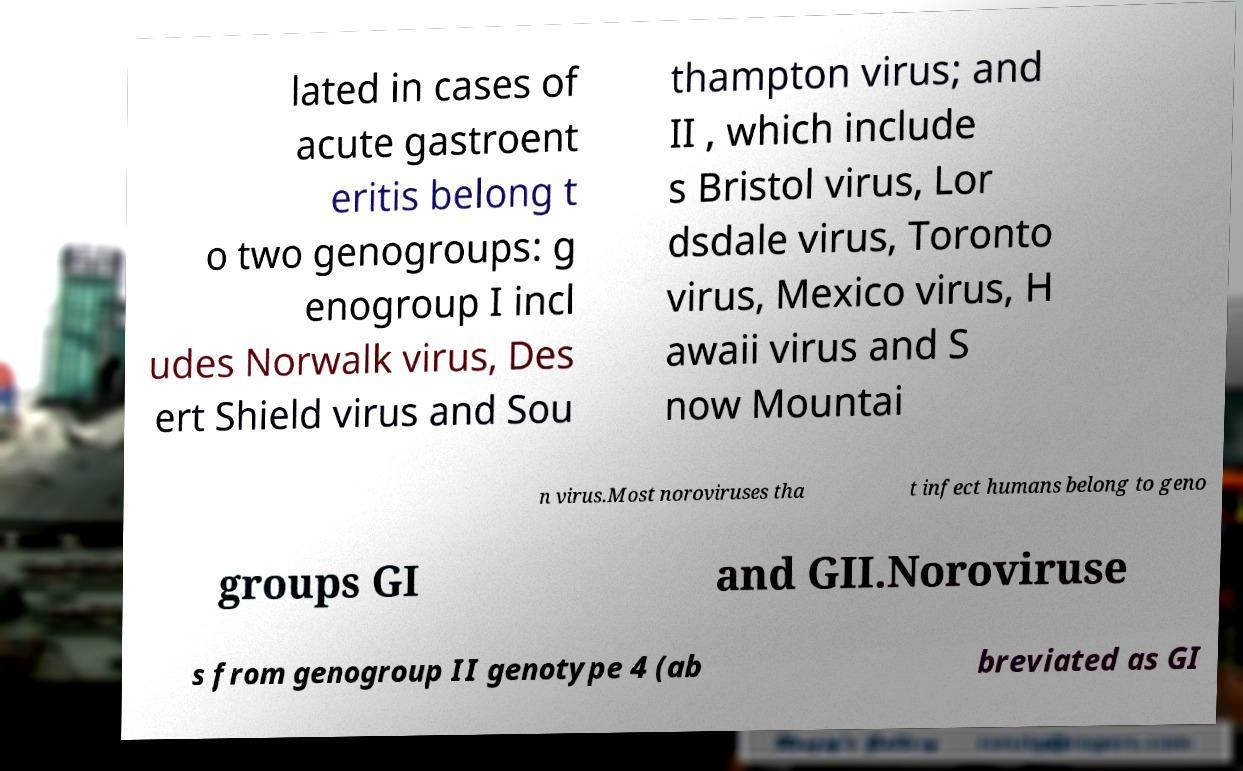Can you read and provide the text displayed in the image?This photo seems to have some interesting text. Can you extract and type it out for me? lated in cases of acute gastroent eritis belong t o two genogroups: g enogroup I incl udes Norwalk virus, Des ert Shield virus and Sou thampton virus; and II , which include s Bristol virus, Lor dsdale virus, Toronto virus, Mexico virus, H awaii virus and S now Mountai n virus.Most noroviruses tha t infect humans belong to geno groups GI and GII.Noroviruse s from genogroup II genotype 4 (ab breviated as GI 